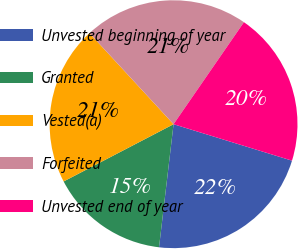Convert chart. <chart><loc_0><loc_0><loc_500><loc_500><pie_chart><fcel>Unvested beginning of year<fcel>Granted<fcel>Vested(a)<fcel>Forfeited<fcel>Unvested end of year<nl><fcel>22.12%<fcel>15.49%<fcel>20.78%<fcel>21.48%<fcel>20.14%<nl></chart> 